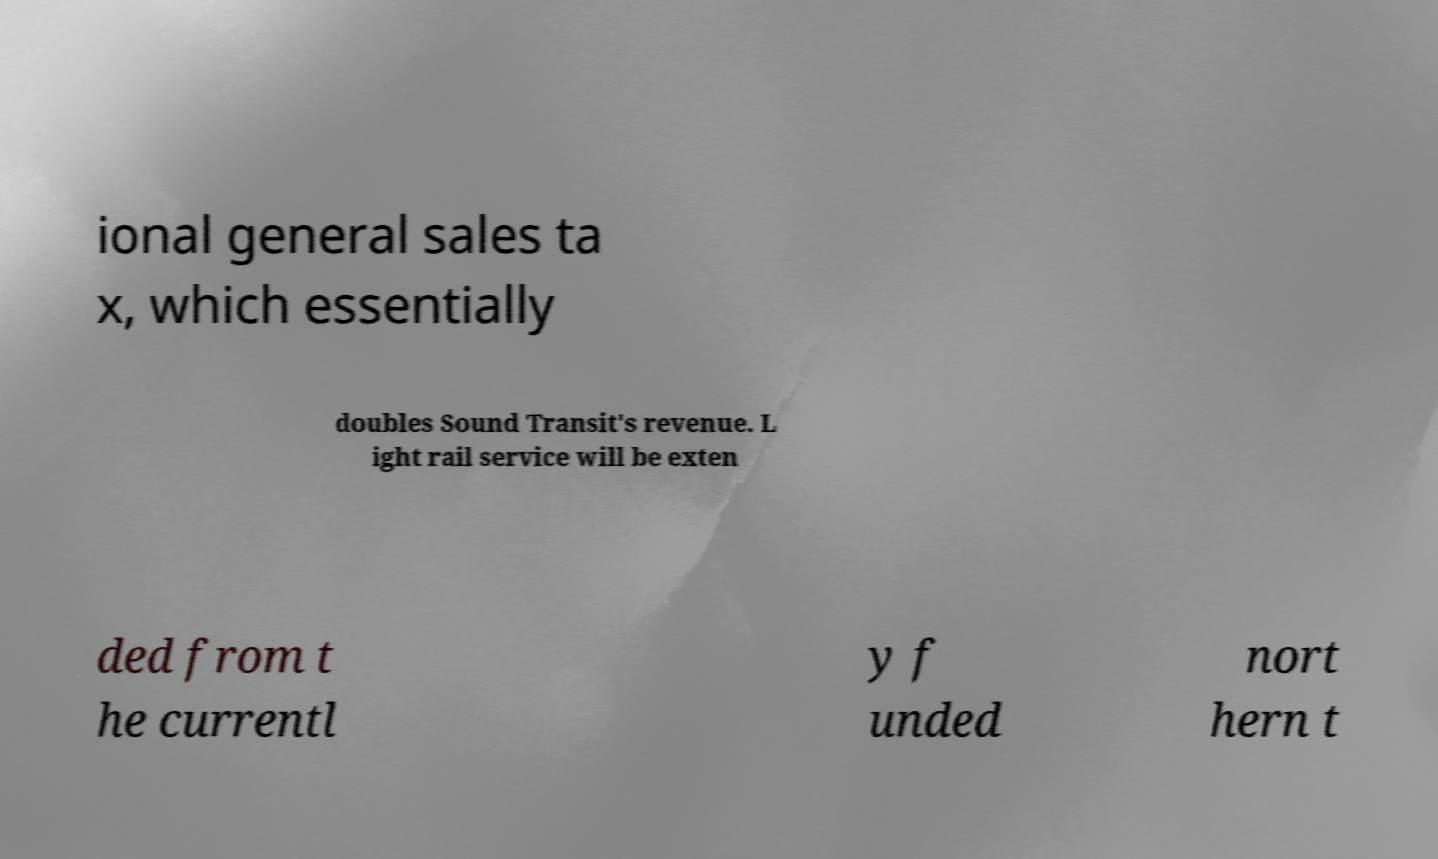There's text embedded in this image that I need extracted. Can you transcribe it verbatim? ional general sales ta x, which essentially doubles Sound Transit's revenue. L ight rail service will be exten ded from t he currentl y f unded nort hern t 